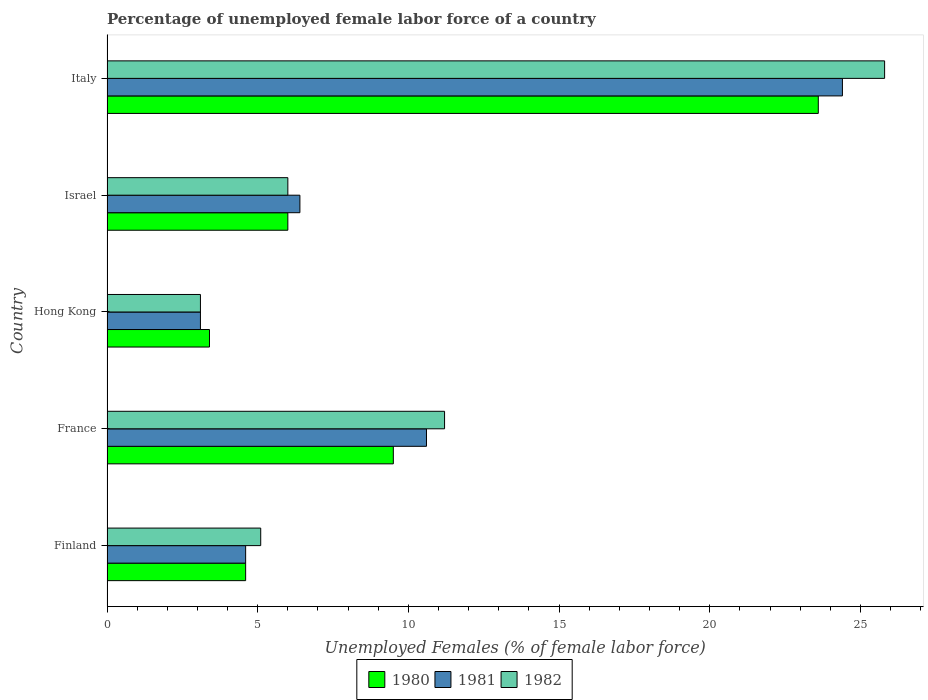Are the number of bars on each tick of the Y-axis equal?
Provide a succinct answer. Yes. How many bars are there on the 5th tick from the top?
Provide a short and direct response. 3. How many bars are there on the 5th tick from the bottom?
Ensure brevity in your answer.  3. What is the label of the 2nd group of bars from the top?
Offer a very short reply. Israel. In how many cases, is the number of bars for a given country not equal to the number of legend labels?
Your response must be concise. 0. What is the percentage of unemployed female labor force in 1981 in Hong Kong?
Make the answer very short. 3.1. Across all countries, what is the maximum percentage of unemployed female labor force in 1980?
Give a very brief answer. 23.6. Across all countries, what is the minimum percentage of unemployed female labor force in 1982?
Your answer should be very brief. 3.1. In which country was the percentage of unemployed female labor force in 1982 maximum?
Provide a short and direct response. Italy. In which country was the percentage of unemployed female labor force in 1981 minimum?
Provide a succinct answer. Hong Kong. What is the total percentage of unemployed female labor force in 1980 in the graph?
Your response must be concise. 47.1. What is the difference between the percentage of unemployed female labor force in 1980 in Hong Kong and that in Italy?
Your response must be concise. -20.2. What is the difference between the percentage of unemployed female labor force in 1982 in Israel and the percentage of unemployed female labor force in 1981 in France?
Your answer should be compact. -4.6. What is the average percentage of unemployed female labor force in 1981 per country?
Offer a terse response. 9.82. What is the difference between the percentage of unemployed female labor force in 1981 and percentage of unemployed female labor force in 1982 in Finland?
Your answer should be very brief. -0.5. In how many countries, is the percentage of unemployed female labor force in 1980 greater than 18 %?
Your answer should be compact. 1. What is the ratio of the percentage of unemployed female labor force in 1982 in Israel to that in Italy?
Your answer should be very brief. 0.23. Is the difference between the percentage of unemployed female labor force in 1981 in France and Israel greater than the difference between the percentage of unemployed female labor force in 1982 in France and Israel?
Make the answer very short. No. What is the difference between the highest and the second highest percentage of unemployed female labor force in 1980?
Ensure brevity in your answer.  14.1. What is the difference between the highest and the lowest percentage of unemployed female labor force in 1980?
Give a very brief answer. 20.2. In how many countries, is the percentage of unemployed female labor force in 1981 greater than the average percentage of unemployed female labor force in 1981 taken over all countries?
Your answer should be very brief. 2. Is the sum of the percentage of unemployed female labor force in 1982 in France and Israel greater than the maximum percentage of unemployed female labor force in 1981 across all countries?
Your answer should be very brief. No. What does the 2nd bar from the bottom in France represents?
Provide a short and direct response. 1981. How many bars are there?
Ensure brevity in your answer.  15. Are all the bars in the graph horizontal?
Keep it short and to the point. Yes. Are the values on the major ticks of X-axis written in scientific E-notation?
Provide a short and direct response. No. Does the graph contain any zero values?
Your response must be concise. No. How many legend labels are there?
Offer a terse response. 3. What is the title of the graph?
Offer a very short reply. Percentage of unemployed female labor force of a country. What is the label or title of the X-axis?
Provide a short and direct response. Unemployed Females (% of female labor force). What is the label or title of the Y-axis?
Your answer should be compact. Country. What is the Unemployed Females (% of female labor force) of 1980 in Finland?
Offer a terse response. 4.6. What is the Unemployed Females (% of female labor force) in 1981 in Finland?
Offer a terse response. 4.6. What is the Unemployed Females (% of female labor force) of 1982 in Finland?
Provide a succinct answer. 5.1. What is the Unemployed Females (% of female labor force) of 1981 in France?
Offer a terse response. 10.6. What is the Unemployed Females (% of female labor force) in 1982 in France?
Your answer should be very brief. 11.2. What is the Unemployed Females (% of female labor force) of 1980 in Hong Kong?
Give a very brief answer. 3.4. What is the Unemployed Females (% of female labor force) in 1981 in Hong Kong?
Your answer should be compact. 3.1. What is the Unemployed Females (% of female labor force) of 1982 in Hong Kong?
Provide a succinct answer. 3.1. What is the Unemployed Females (% of female labor force) in 1980 in Israel?
Provide a succinct answer. 6. What is the Unemployed Females (% of female labor force) in 1981 in Israel?
Ensure brevity in your answer.  6.4. What is the Unemployed Females (% of female labor force) of 1982 in Israel?
Your response must be concise. 6. What is the Unemployed Females (% of female labor force) in 1980 in Italy?
Offer a very short reply. 23.6. What is the Unemployed Females (% of female labor force) in 1981 in Italy?
Make the answer very short. 24.4. What is the Unemployed Females (% of female labor force) of 1982 in Italy?
Provide a short and direct response. 25.8. Across all countries, what is the maximum Unemployed Females (% of female labor force) of 1980?
Your response must be concise. 23.6. Across all countries, what is the maximum Unemployed Females (% of female labor force) of 1981?
Offer a terse response. 24.4. Across all countries, what is the maximum Unemployed Females (% of female labor force) of 1982?
Offer a very short reply. 25.8. Across all countries, what is the minimum Unemployed Females (% of female labor force) of 1980?
Make the answer very short. 3.4. Across all countries, what is the minimum Unemployed Females (% of female labor force) in 1981?
Ensure brevity in your answer.  3.1. Across all countries, what is the minimum Unemployed Females (% of female labor force) of 1982?
Ensure brevity in your answer.  3.1. What is the total Unemployed Females (% of female labor force) of 1980 in the graph?
Provide a short and direct response. 47.1. What is the total Unemployed Females (% of female labor force) of 1981 in the graph?
Keep it short and to the point. 49.1. What is the total Unemployed Females (% of female labor force) of 1982 in the graph?
Provide a succinct answer. 51.2. What is the difference between the Unemployed Females (% of female labor force) of 1982 in Finland and that in France?
Keep it short and to the point. -6.1. What is the difference between the Unemployed Females (% of female labor force) of 1981 in Finland and that in Hong Kong?
Give a very brief answer. 1.5. What is the difference between the Unemployed Females (% of female labor force) in 1982 in Finland and that in Hong Kong?
Your answer should be compact. 2. What is the difference between the Unemployed Females (% of female labor force) of 1982 in Finland and that in Israel?
Provide a short and direct response. -0.9. What is the difference between the Unemployed Females (% of female labor force) in 1981 in Finland and that in Italy?
Your answer should be very brief. -19.8. What is the difference between the Unemployed Females (% of female labor force) of 1982 in Finland and that in Italy?
Give a very brief answer. -20.7. What is the difference between the Unemployed Females (% of female labor force) in 1980 in France and that in Hong Kong?
Give a very brief answer. 6.1. What is the difference between the Unemployed Females (% of female labor force) of 1981 in France and that in Israel?
Provide a succinct answer. 4.2. What is the difference between the Unemployed Females (% of female labor force) in 1982 in France and that in Israel?
Provide a succinct answer. 5.2. What is the difference between the Unemployed Females (% of female labor force) in 1980 in France and that in Italy?
Offer a terse response. -14.1. What is the difference between the Unemployed Females (% of female labor force) in 1982 in France and that in Italy?
Offer a very short reply. -14.6. What is the difference between the Unemployed Females (% of female labor force) of 1981 in Hong Kong and that in Israel?
Your response must be concise. -3.3. What is the difference between the Unemployed Females (% of female labor force) in 1980 in Hong Kong and that in Italy?
Provide a succinct answer. -20.2. What is the difference between the Unemployed Females (% of female labor force) in 1981 in Hong Kong and that in Italy?
Your answer should be compact. -21.3. What is the difference between the Unemployed Females (% of female labor force) in 1982 in Hong Kong and that in Italy?
Offer a very short reply. -22.7. What is the difference between the Unemployed Females (% of female labor force) of 1980 in Israel and that in Italy?
Offer a very short reply. -17.6. What is the difference between the Unemployed Females (% of female labor force) of 1982 in Israel and that in Italy?
Ensure brevity in your answer.  -19.8. What is the difference between the Unemployed Females (% of female labor force) of 1980 in Finland and the Unemployed Females (% of female labor force) of 1982 in France?
Keep it short and to the point. -6.6. What is the difference between the Unemployed Females (% of female labor force) in 1981 in Finland and the Unemployed Females (% of female labor force) in 1982 in France?
Ensure brevity in your answer.  -6.6. What is the difference between the Unemployed Females (% of female labor force) in 1980 in Finland and the Unemployed Females (% of female labor force) in 1981 in Hong Kong?
Ensure brevity in your answer.  1.5. What is the difference between the Unemployed Females (% of female labor force) of 1980 in Finland and the Unemployed Females (% of female labor force) of 1982 in Hong Kong?
Offer a very short reply. 1.5. What is the difference between the Unemployed Females (% of female labor force) in 1981 in Finland and the Unemployed Females (% of female labor force) in 1982 in Hong Kong?
Your response must be concise. 1.5. What is the difference between the Unemployed Females (% of female labor force) of 1980 in Finland and the Unemployed Females (% of female labor force) of 1981 in Israel?
Offer a very short reply. -1.8. What is the difference between the Unemployed Females (% of female labor force) in 1981 in Finland and the Unemployed Females (% of female labor force) in 1982 in Israel?
Provide a succinct answer. -1.4. What is the difference between the Unemployed Females (% of female labor force) of 1980 in Finland and the Unemployed Females (% of female labor force) of 1981 in Italy?
Give a very brief answer. -19.8. What is the difference between the Unemployed Females (% of female labor force) in 1980 in Finland and the Unemployed Females (% of female labor force) in 1982 in Italy?
Provide a succinct answer. -21.2. What is the difference between the Unemployed Females (% of female labor force) of 1981 in Finland and the Unemployed Females (% of female labor force) of 1982 in Italy?
Your response must be concise. -21.2. What is the difference between the Unemployed Females (% of female labor force) in 1980 in France and the Unemployed Females (% of female labor force) in 1981 in Hong Kong?
Provide a succinct answer. 6.4. What is the difference between the Unemployed Females (% of female labor force) of 1980 in France and the Unemployed Females (% of female labor force) of 1982 in Hong Kong?
Provide a short and direct response. 6.4. What is the difference between the Unemployed Females (% of female labor force) of 1981 in France and the Unemployed Females (% of female labor force) of 1982 in Hong Kong?
Make the answer very short. 7.5. What is the difference between the Unemployed Females (% of female labor force) in 1980 in France and the Unemployed Females (% of female labor force) in 1982 in Israel?
Keep it short and to the point. 3.5. What is the difference between the Unemployed Females (% of female labor force) of 1980 in France and the Unemployed Females (% of female labor force) of 1981 in Italy?
Make the answer very short. -14.9. What is the difference between the Unemployed Females (% of female labor force) of 1980 in France and the Unemployed Females (% of female labor force) of 1982 in Italy?
Give a very brief answer. -16.3. What is the difference between the Unemployed Females (% of female labor force) of 1981 in France and the Unemployed Females (% of female labor force) of 1982 in Italy?
Your answer should be very brief. -15.2. What is the difference between the Unemployed Females (% of female labor force) in 1981 in Hong Kong and the Unemployed Females (% of female labor force) in 1982 in Israel?
Make the answer very short. -2.9. What is the difference between the Unemployed Females (% of female labor force) in 1980 in Hong Kong and the Unemployed Females (% of female labor force) in 1982 in Italy?
Your answer should be compact. -22.4. What is the difference between the Unemployed Females (% of female labor force) of 1981 in Hong Kong and the Unemployed Females (% of female labor force) of 1982 in Italy?
Offer a very short reply. -22.7. What is the difference between the Unemployed Females (% of female labor force) in 1980 in Israel and the Unemployed Females (% of female labor force) in 1981 in Italy?
Provide a succinct answer. -18.4. What is the difference between the Unemployed Females (% of female labor force) of 1980 in Israel and the Unemployed Females (% of female labor force) of 1982 in Italy?
Ensure brevity in your answer.  -19.8. What is the difference between the Unemployed Females (% of female labor force) of 1981 in Israel and the Unemployed Females (% of female labor force) of 1982 in Italy?
Offer a terse response. -19.4. What is the average Unemployed Females (% of female labor force) of 1980 per country?
Provide a short and direct response. 9.42. What is the average Unemployed Females (% of female labor force) in 1981 per country?
Provide a succinct answer. 9.82. What is the average Unemployed Females (% of female labor force) in 1982 per country?
Ensure brevity in your answer.  10.24. What is the difference between the Unemployed Females (% of female labor force) in 1980 and Unemployed Females (% of female labor force) in 1982 in Finland?
Keep it short and to the point. -0.5. What is the difference between the Unemployed Females (% of female labor force) in 1981 and Unemployed Females (% of female labor force) in 1982 in Finland?
Offer a very short reply. -0.5. What is the difference between the Unemployed Females (% of female labor force) of 1980 and Unemployed Females (% of female labor force) of 1981 in France?
Provide a short and direct response. -1.1. What is the difference between the Unemployed Females (% of female labor force) of 1980 and Unemployed Females (% of female labor force) of 1981 in Hong Kong?
Provide a short and direct response. 0.3. What is the difference between the Unemployed Females (% of female labor force) in 1980 and Unemployed Females (% of female labor force) in 1981 in Israel?
Give a very brief answer. -0.4. What is the difference between the Unemployed Females (% of female labor force) in 1981 and Unemployed Females (% of female labor force) in 1982 in Israel?
Your answer should be very brief. 0.4. What is the difference between the Unemployed Females (% of female labor force) of 1980 and Unemployed Females (% of female labor force) of 1982 in Italy?
Provide a succinct answer. -2.2. What is the difference between the Unemployed Females (% of female labor force) of 1981 and Unemployed Females (% of female labor force) of 1982 in Italy?
Your response must be concise. -1.4. What is the ratio of the Unemployed Females (% of female labor force) of 1980 in Finland to that in France?
Offer a terse response. 0.48. What is the ratio of the Unemployed Females (% of female labor force) in 1981 in Finland to that in France?
Keep it short and to the point. 0.43. What is the ratio of the Unemployed Females (% of female labor force) of 1982 in Finland to that in France?
Give a very brief answer. 0.46. What is the ratio of the Unemployed Females (% of female labor force) in 1980 in Finland to that in Hong Kong?
Your response must be concise. 1.35. What is the ratio of the Unemployed Females (% of female labor force) in 1981 in Finland to that in Hong Kong?
Your answer should be compact. 1.48. What is the ratio of the Unemployed Females (% of female labor force) of 1982 in Finland to that in Hong Kong?
Give a very brief answer. 1.65. What is the ratio of the Unemployed Females (% of female labor force) in 1980 in Finland to that in Israel?
Your answer should be very brief. 0.77. What is the ratio of the Unemployed Females (% of female labor force) in 1981 in Finland to that in Israel?
Give a very brief answer. 0.72. What is the ratio of the Unemployed Females (% of female labor force) in 1980 in Finland to that in Italy?
Provide a succinct answer. 0.19. What is the ratio of the Unemployed Females (% of female labor force) of 1981 in Finland to that in Italy?
Offer a terse response. 0.19. What is the ratio of the Unemployed Females (% of female labor force) in 1982 in Finland to that in Italy?
Give a very brief answer. 0.2. What is the ratio of the Unemployed Females (% of female labor force) of 1980 in France to that in Hong Kong?
Your answer should be very brief. 2.79. What is the ratio of the Unemployed Females (% of female labor force) of 1981 in France to that in Hong Kong?
Give a very brief answer. 3.42. What is the ratio of the Unemployed Females (% of female labor force) of 1982 in France to that in Hong Kong?
Your answer should be very brief. 3.61. What is the ratio of the Unemployed Females (% of female labor force) in 1980 in France to that in Israel?
Provide a short and direct response. 1.58. What is the ratio of the Unemployed Females (% of female labor force) of 1981 in France to that in Israel?
Your answer should be compact. 1.66. What is the ratio of the Unemployed Females (% of female labor force) of 1982 in France to that in Israel?
Give a very brief answer. 1.87. What is the ratio of the Unemployed Females (% of female labor force) of 1980 in France to that in Italy?
Ensure brevity in your answer.  0.4. What is the ratio of the Unemployed Females (% of female labor force) in 1981 in France to that in Italy?
Give a very brief answer. 0.43. What is the ratio of the Unemployed Females (% of female labor force) in 1982 in France to that in Italy?
Offer a terse response. 0.43. What is the ratio of the Unemployed Females (% of female labor force) of 1980 in Hong Kong to that in Israel?
Your response must be concise. 0.57. What is the ratio of the Unemployed Females (% of female labor force) of 1981 in Hong Kong to that in Israel?
Provide a succinct answer. 0.48. What is the ratio of the Unemployed Females (% of female labor force) of 1982 in Hong Kong to that in Israel?
Provide a short and direct response. 0.52. What is the ratio of the Unemployed Females (% of female labor force) of 1980 in Hong Kong to that in Italy?
Give a very brief answer. 0.14. What is the ratio of the Unemployed Females (% of female labor force) of 1981 in Hong Kong to that in Italy?
Your answer should be compact. 0.13. What is the ratio of the Unemployed Females (% of female labor force) of 1982 in Hong Kong to that in Italy?
Give a very brief answer. 0.12. What is the ratio of the Unemployed Females (% of female labor force) in 1980 in Israel to that in Italy?
Offer a terse response. 0.25. What is the ratio of the Unemployed Females (% of female labor force) of 1981 in Israel to that in Italy?
Ensure brevity in your answer.  0.26. What is the ratio of the Unemployed Females (% of female labor force) of 1982 in Israel to that in Italy?
Your answer should be compact. 0.23. What is the difference between the highest and the second highest Unemployed Females (% of female labor force) of 1982?
Give a very brief answer. 14.6. What is the difference between the highest and the lowest Unemployed Females (% of female labor force) of 1980?
Make the answer very short. 20.2. What is the difference between the highest and the lowest Unemployed Females (% of female labor force) in 1981?
Offer a terse response. 21.3. What is the difference between the highest and the lowest Unemployed Females (% of female labor force) of 1982?
Your response must be concise. 22.7. 